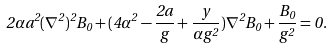<formula> <loc_0><loc_0><loc_500><loc_500>2 \alpha a ^ { 2 } ( \nabla ^ { 2 } ) ^ { 2 } B _ { 0 } + ( 4 \alpha ^ { 2 } - \frac { 2 a } { g } + \frac { y } { \alpha g ^ { 2 } } ) \nabla ^ { 2 } B _ { 0 } + \frac { B _ { 0 } } { g ^ { 2 } } = 0 .</formula> 